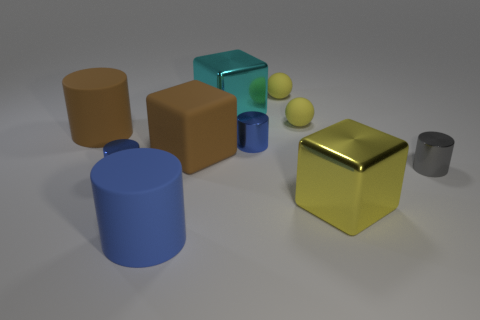What is the shape of the tiny blue metal thing that is on the right side of the metallic block that is behind the big matte cylinder behind the tiny gray shiny cylinder?
Give a very brief answer. Cylinder. How many cylinders are behind the cyan cube?
Your answer should be very brief. 0. Do the tiny sphere in front of the cyan metallic thing and the gray cylinder have the same material?
Provide a succinct answer. No. What number of other objects are the same shape as the large yellow metal thing?
Offer a terse response. 2. There is a blue cylinder that is right of the brown object on the right side of the brown rubber cylinder; how many tiny blue metallic things are behind it?
Ensure brevity in your answer.  0. There is a matte cylinder behind the blue matte cylinder; what is its color?
Give a very brief answer. Brown. There is a big rubber cylinder that is behind the large yellow shiny object; is its color the same as the big rubber cube?
Keep it short and to the point. Yes. What is the size of the other metal thing that is the same shape as the large yellow object?
Give a very brief answer. Large. Is there anything else that has the same size as the gray cylinder?
Provide a succinct answer. Yes. What material is the small blue cylinder that is left of the big brown matte object that is to the right of the large matte cylinder that is on the right side of the big brown cylinder?
Provide a short and direct response. Metal. 